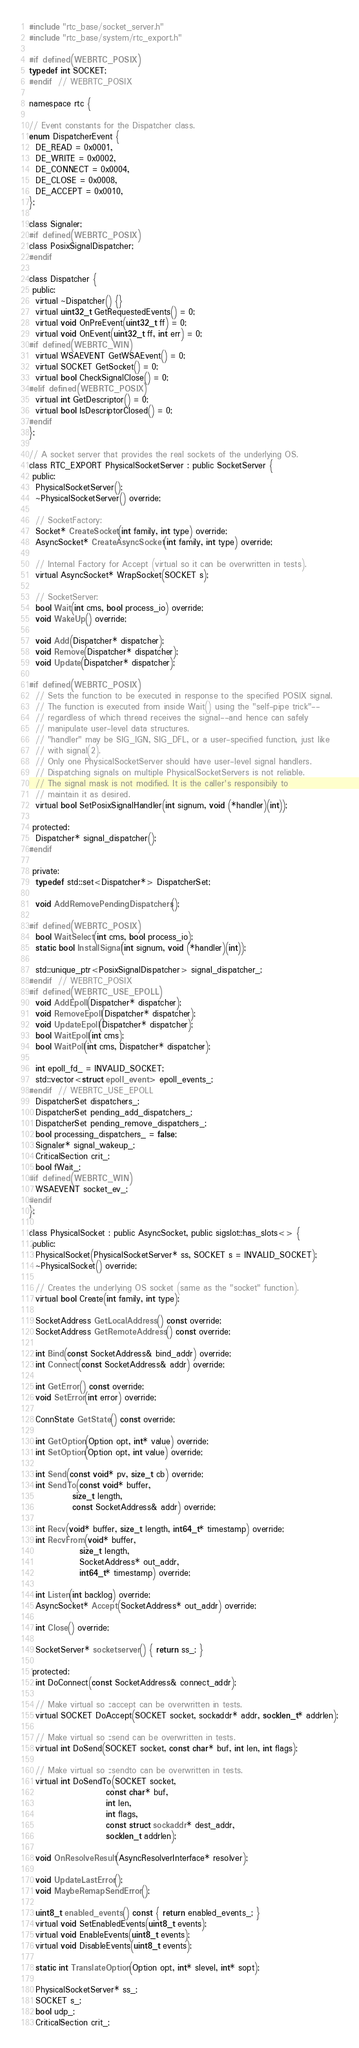<code> <loc_0><loc_0><loc_500><loc_500><_C_>#include "rtc_base/socket_server.h"
#include "rtc_base/system/rtc_export.h"

#if defined(WEBRTC_POSIX)
typedef int SOCKET;
#endif  // WEBRTC_POSIX

namespace rtc {

// Event constants for the Dispatcher class.
enum DispatcherEvent {
  DE_READ = 0x0001,
  DE_WRITE = 0x0002,
  DE_CONNECT = 0x0004,
  DE_CLOSE = 0x0008,
  DE_ACCEPT = 0x0010,
};

class Signaler;
#if defined(WEBRTC_POSIX)
class PosixSignalDispatcher;
#endif

class Dispatcher {
 public:
  virtual ~Dispatcher() {}
  virtual uint32_t GetRequestedEvents() = 0;
  virtual void OnPreEvent(uint32_t ff) = 0;
  virtual void OnEvent(uint32_t ff, int err) = 0;
#if defined(WEBRTC_WIN)
  virtual WSAEVENT GetWSAEvent() = 0;
  virtual SOCKET GetSocket() = 0;
  virtual bool CheckSignalClose() = 0;
#elif defined(WEBRTC_POSIX)
  virtual int GetDescriptor() = 0;
  virtual bool IsDescriptorClosed() = 0;
#endif
};

// A socket server that provides the real sockets of the underlying OS.
class RTC_EXPORT PhysicalSocketServer : public SocketServer {
 public:
  PhysicalSocketServer();
  ~PhysicalSocketServer() override;

  // SocketFactory:
  Socket* CreateSocket(int family, int type) override;
  AsyncSocket* CreateAsyncSocket(int family, int type) override;

  // Internal Factory for Accept (virtual so it can be overwritten in tests).
  virtual AsyncSocket* WrapSocket(SOCKET s);

  // SocketServer:
  bool Wait(int cms, bool process_io) override;
  void WakeUp() override;

  void Add(Dispatcher* dispatcher);
  void Remove(Dispatcher* dispatcher);
  void Update(Dispatcher* dispatcher);

#if defined(WEBRTC_POSIX)
  // Sets the function to be executed in response to the specified POSIX signal.
  // The function is executed from inside Wait() using the "self-pipe trick"--
  // regardless of which thread receives the signal--and hence can safely
  // manipulate user-level data structures.
  // "handler" may be SIG_IGN, SIG_DFL, or a user-specified function, just like
  // with signal(2).
  // Only one PhysicalSocketServer should have user-level signal handlers.
  // Dispatching signals on multiple PhysicalSocketServers is not reliable.
  // The signal mask is not modified. It is the caller's responsibily to
  // maintain it as desired.
  virtual bool SetPosixSignalHandler(int signum, void (*handler)(int));

 protected:
  Dispatcher* signal_dispatcher();
#endif

 private:
  typedef std::set<Dispatcher*> DispatcherSet;

  void AddRemovePendingDispatchers();

#if defined(WEBRTC_POSIX)
  bool WaitSelect(int cms, bool process_io);
  static bool InstallSignal(int signum, void (*handler)(int));

  std::unique_ptr<PosixSignalDispatcher> signal_dispatcher_;
#endif  // WEBRTC_POSIX
#if defined(WEBRTC_USE_EPOLL)
  void AddEpoll(Dispatcher* dispatcher);
  void RemoveEpoll(Dispatcher* dispatcher);
  void UpdateEpoll(Dispatcher* dispatcher);
  bool WaitEpoll(int cms);
  bool WaitPoll(int cms, Dispatcher* dispatcher);

  int epoll_fd_ = INVALID_SOCKET;
  std::vector<struct epoll_event> epoll_events_;
#endif  // WEBRTC_USE_EPOLL
  DispatcherSet dispatchers_;
  DispatcherSet pending_add_dispatchers_;
  DispatcherSet pending_remove_dispatchers_;
  bool processing_dispatchers_ = false;
  Signaler* signal_wakeup_;
  CriticalSection crit_;
  bool fWait_;
#if defined(WEBRTC_WIN)
  WSAEVENT socket_ev_;
#endif
};

class PhysicalSocket : public AsyncSocket, public sigslot::has_slots<> {
 public:
  PhysicalSocket(PhysicalSocketServer* ss, SOCKET s = INVALID_SOCKET);
  ~PhysicalSocket() override;

  // Creates the underlying OS socket (same as the "socket" function).
  virtual bool Create(int family, int type);

  SocketAddress GetLocalAddress() const override;
  SocketAddress GetRemoteAddress() const override;

  int Bind(const SocketAddress& bind_addr) override;
  int Connect(const SocketAddress& addr) override;

  int GetError() const override;
  void SetError(int error) override;

  ConnState GetState() const override;

  int GetOption(Option opt, int* value) override;
  int SetOption(Option opt, int value) override;

  int Send(const void* pv, size_t cb) override;
  int SendTo(const void* buffer,
             size_t length,
             const SocketAddress& addr) override;

  int Recv(void* buffer, size_t length, int64_t* timestamp) override;
  int RecvFrom(void* buffer,
               size_t length,
               SocketAddress* out_addr,
               int64_t* timestamp) override;

  int Listen(int backlog) override;
  AsyncSocket* Accept(SocketAddress* out_addr) override;

  int Close() override;

  SocketServer* socketserver() { return ss_; }

 protected:
  int DoConnect(const SocketAddress& connect_addr);

  // Make virtual so ::accept can be overwritten in tests.
  virtual SOCKET DoAccept(SOCKET socket, sockaddr* addr, socklen_t* addrlen);

  // Make virtual so ::send can be overwritten in tests.
  virtual int DoSend(SOCKET socket, const char* buf, int len, int flags);

  // Make virtual so ::sendto can be overwritten in tests.
  virtual int DoSendTo(SOCKET socket,
                       const char* buf,
                       int len,
                       int flags,
                       const struct sockaddr* dest_addr,
                       socklen_t addrlen);

  void OnResolveResult(AsyncResolverInterface* resolver);

  void UpdateLastError();
  void MaybeRemapSendError();

  uint8_t enabled_events() const { return enabled_events_; }
  virtual void SetEnabledEvents(uint8_t events);
  virtual void EnableEvents(uint8_t events);
  virtual void DisableEvents(uint8_t events);

  static int TranslateOption(Option opt, int* slevel, int* sopt);

  PhysicalSocketServer* ss_;
  SOCKET s_;
  bool udp_;
  CriticalSection crit_;</code> 